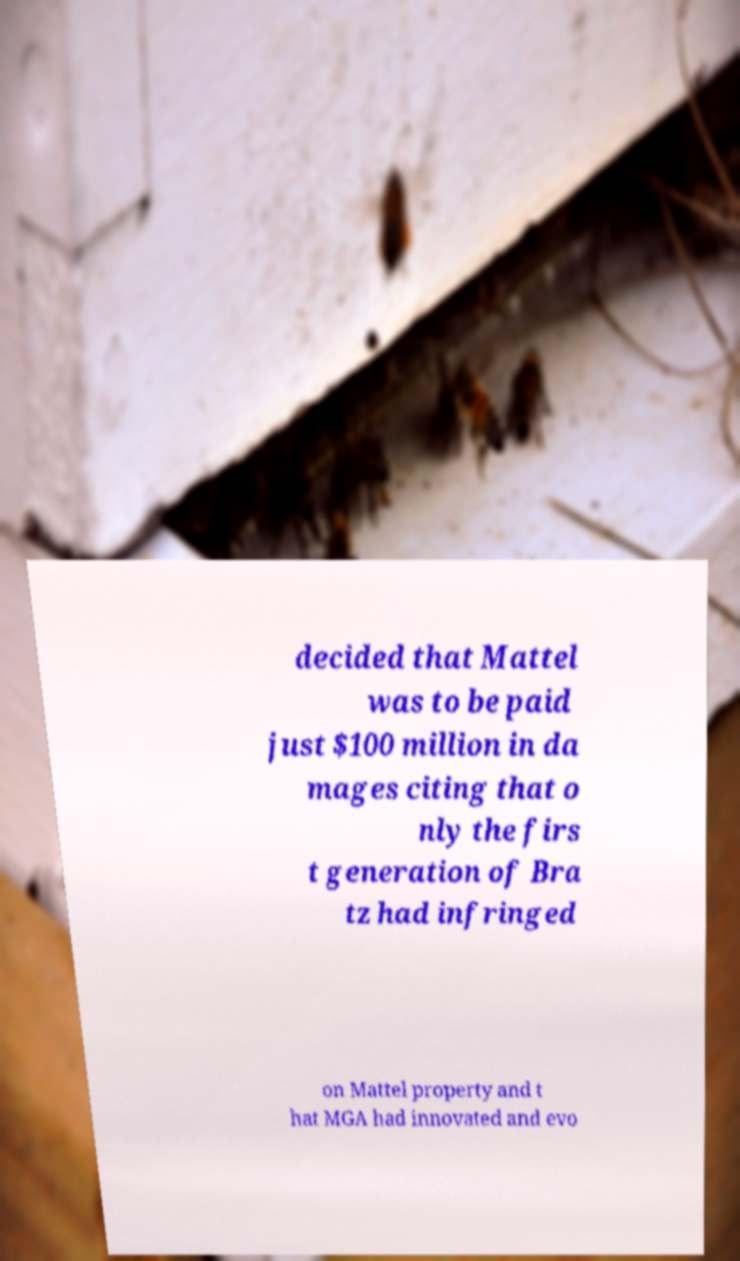Please identify and transcribe the text found in this image. decided that Mattel was to be paid just $100 million in da mages citing that o nly the firs t generation of Bra tz had infringed on Mattel property and t hat MGA had innovated and evo 